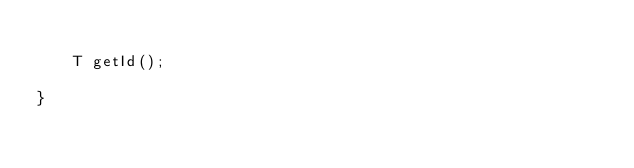<code> <loc_0><loc_0><loc_500><loc_500><_Java_>
    T getId();

}
</code> 